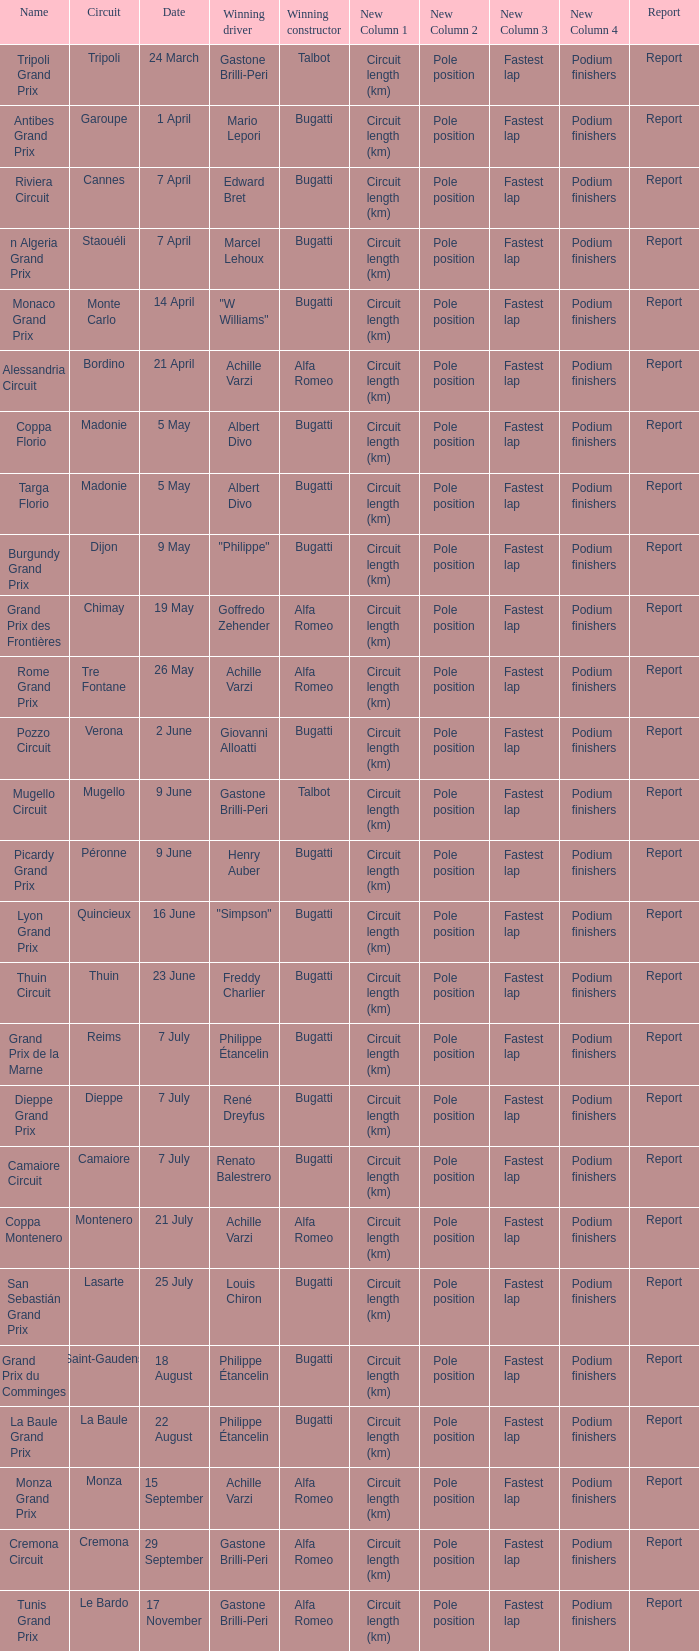What Circuit has a Date of 25 july? Lasarte. 